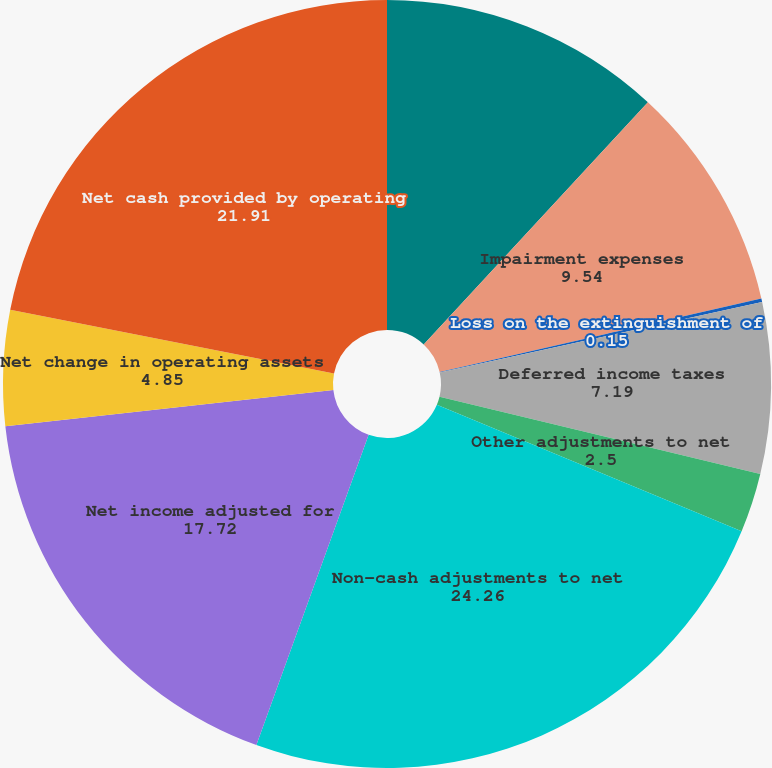<chart> <loc_0><loc_0><loc_500><loc_500><pie_chart><fcel>Depreciation and amortization<fcel>Impairment expenses<fcel>Loss on the extinguishment of<fcel>Deferred income taxes<fcel>Other adjustments to net<fcel>Non-cash adjustments to net<fcel>Net income adjusted for<fcel>Net change in operating assets<fcel>Net cash provided by operating<nl><fcel>11.89%<fcel>9.54%<fcel>0.15%<fcel>7.19%<fcel>2.5%<fcel>24.26%<fcel>17.72%<fcel>4.85%<fcel>21.91%<nl></chart> 